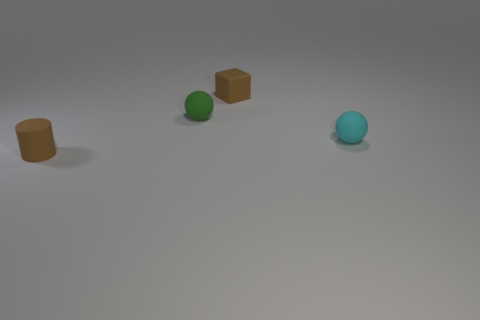Add 4 brown rubber objects. How many objects exist? 8 Subtract 1 balls. How many balls are left? 1 Subtract all cyan spheres. How many spheres are left? 1 Subtract all blue cylinders. How many cyan spheres are left? 1 Subtract all cyan objects. Subtract all small cylinders. How many objects are left? 2 Add 3 cubes. How many cubes are left? 4 Add 2 yellow rubber spheres. How many yellow rubber spheres exist? 2 Subtract 1 brown cylinders. How many objects are left? 3 Subtract all cubes. How many objects are left? 3 Subtract all red balls. Subtract all gray cylinders. How many balls are left? 2 